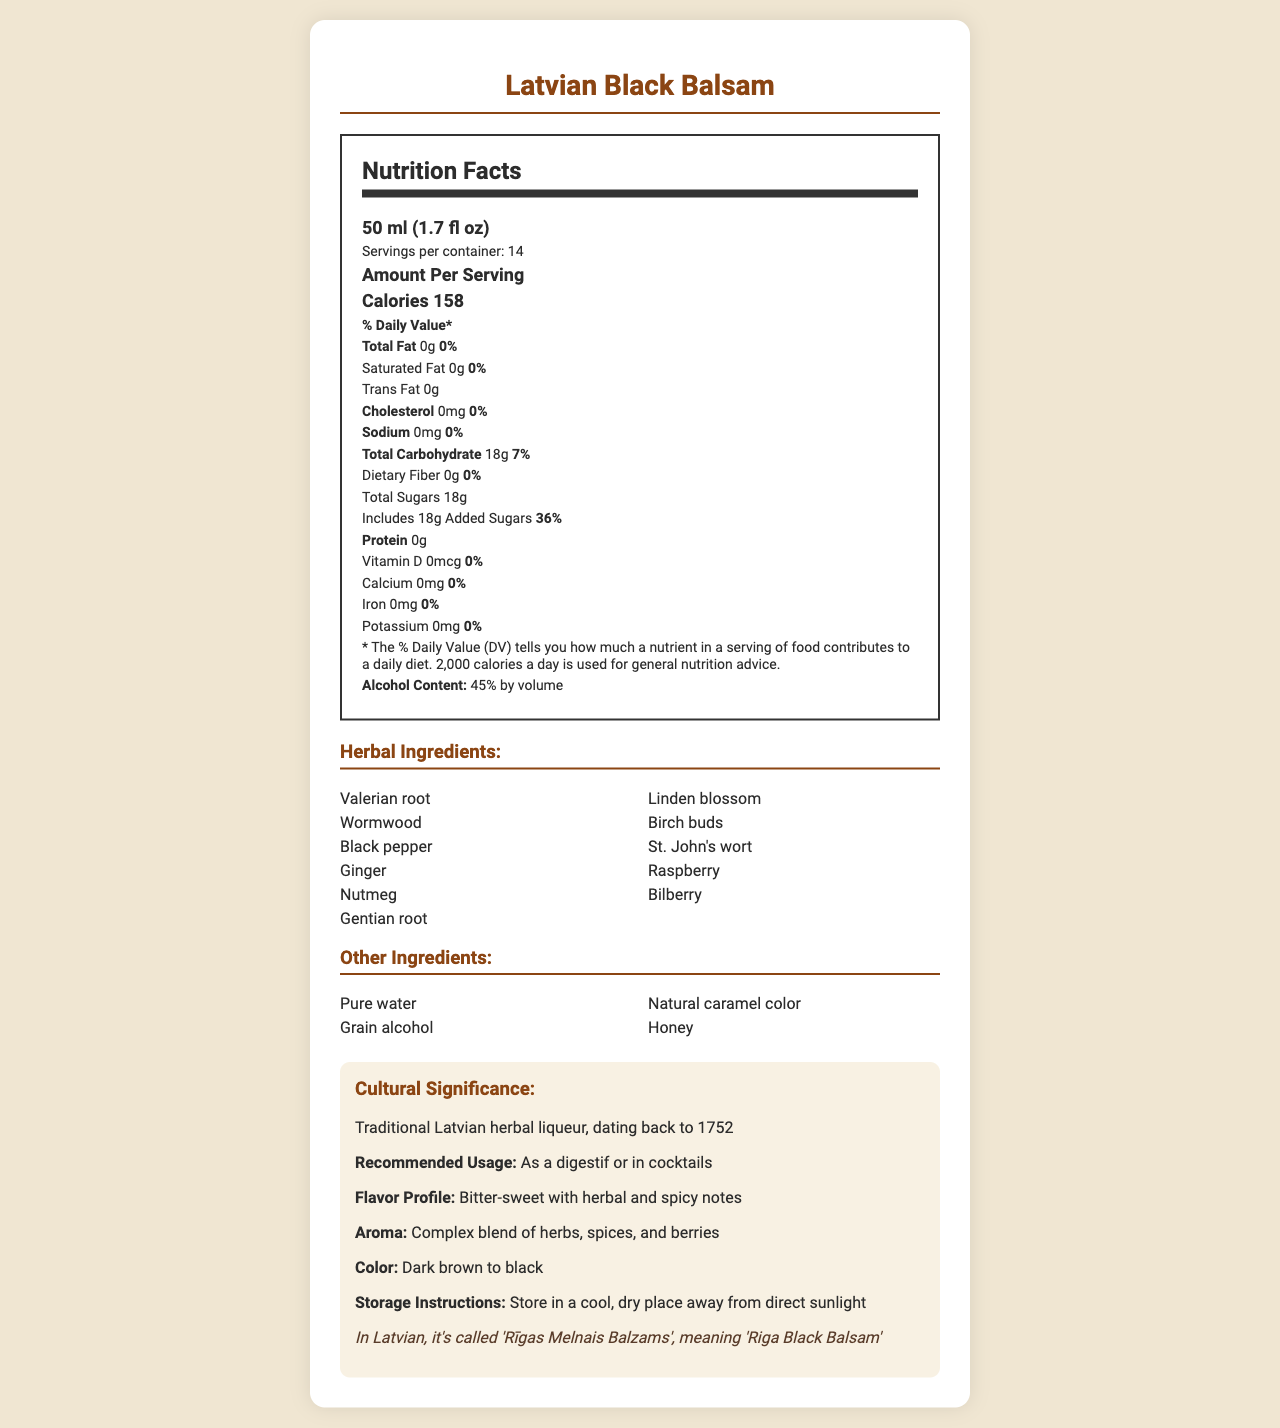what is the serving size of Latvian Black Balsam? The serving size is explicitly stated in the document under the nutrition facts section.
Answer: 50 ml (1.7 fl oz) what is the alcohol content by volume of Latvian Black Balsam? The alcohol content is explicitly mentioned in the document under the nutrition facts section.
Answer: 45% by volume Name three herbal ingredients in Latvian Black Balsam. The herbal ingredients are listed in the ingredients section of the document.
Answer: Valerian root, Wormwood, Black pepper How many calories are there per serving? The calorie count per serving is stated in the nutrition facts section of the document.
Answer: 158 calories what is the recommended usage for Latvian Black Balsam? The recommended usage is stated in the cultural info section of the document.
Answer: As a digestif or in cocktails Which of the following is NOT a listed herbal ingredient in Latvian Black Balsam? A. Ginger B. Nutmeg C. Cinnamon D. St. John's wort The herbal ingredients list includes Ginger, Nutmeg, and St. John's wort but not Cinnamon.
Answer: C. Cinnamon How many grams of total sugar does each serving of Latvian Black Balsam contain? A. 0 grams B. 10 grams C. 18 grams D. 50 grams The document states that each serving contains 18 grams of total sugars in the nutrition facts section.
Answer: C. 18 grams Is there any dietary fiber in Latvian Black Balsam? Yes/No The document states that the dietary fiber content is 0 grams in the nutrition facts section.
Answer: No Summarize the main nutritional and cultural details of Latvian Black Balsam. The summary captures the key nutritional details such as calorie, sugar content, and alcohol percentage, as well as cultural facts about its traditional usage and flavor profile.
Answer: Latvian Black Balsam is a traditional herbal liqueur with 45% alcohol content, commonly used as a digestif or in cocktails. Each 50 ml serving contains 158 calories, 18 grams of total sugars, and no fat or protein. Key ingredients include various herbs and other additives like honey and caramel color. The liqueur is known for its bitter-sweet flavor, complex aroma, and dark color. What is the main export destination for Latvian Black Balsam? The document does not contain any information about export destinations for the product.
Answer: Not enough information What percentage of daily value for total carbohydrates does one serving of Latvian Black Balsam provide? The nutrition facts section states that one serving provides 7% of the daily value for total carbohydrates.
Answer: 7% 